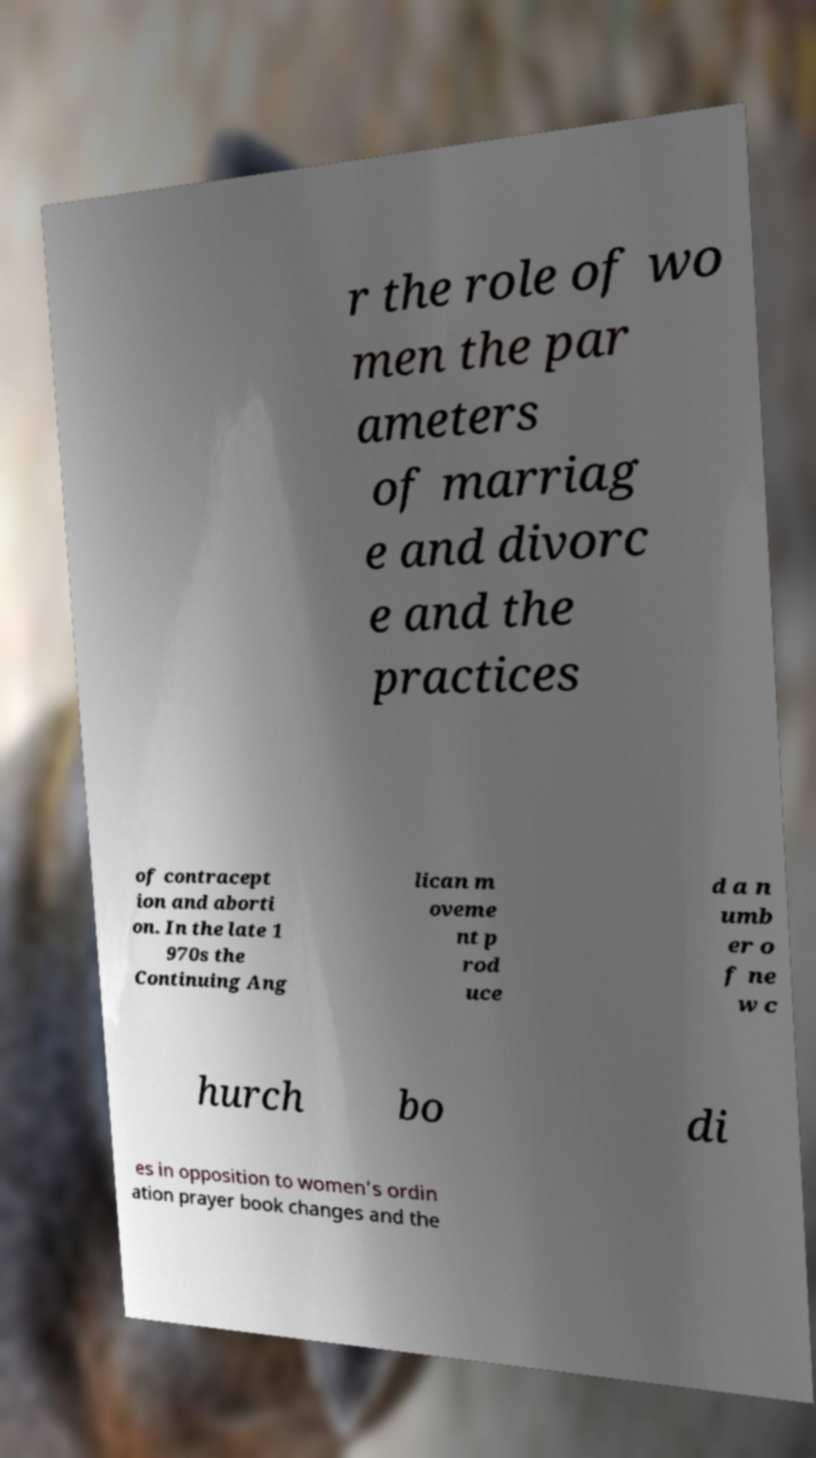Can you read and provide the text displayed in the image?This photo seems to have some interesting text. Can you extract and type it out for me? r the role of wo men the par ameters of marriag e and divorc e and the practices of contracept ion and aborti on. In the late 1 970s the Continuing Ang lican m oveme nt p rod uce d a n umb er o f ne w c hurch bo di es in opposition to women's ordin ation prayer book changes and the 